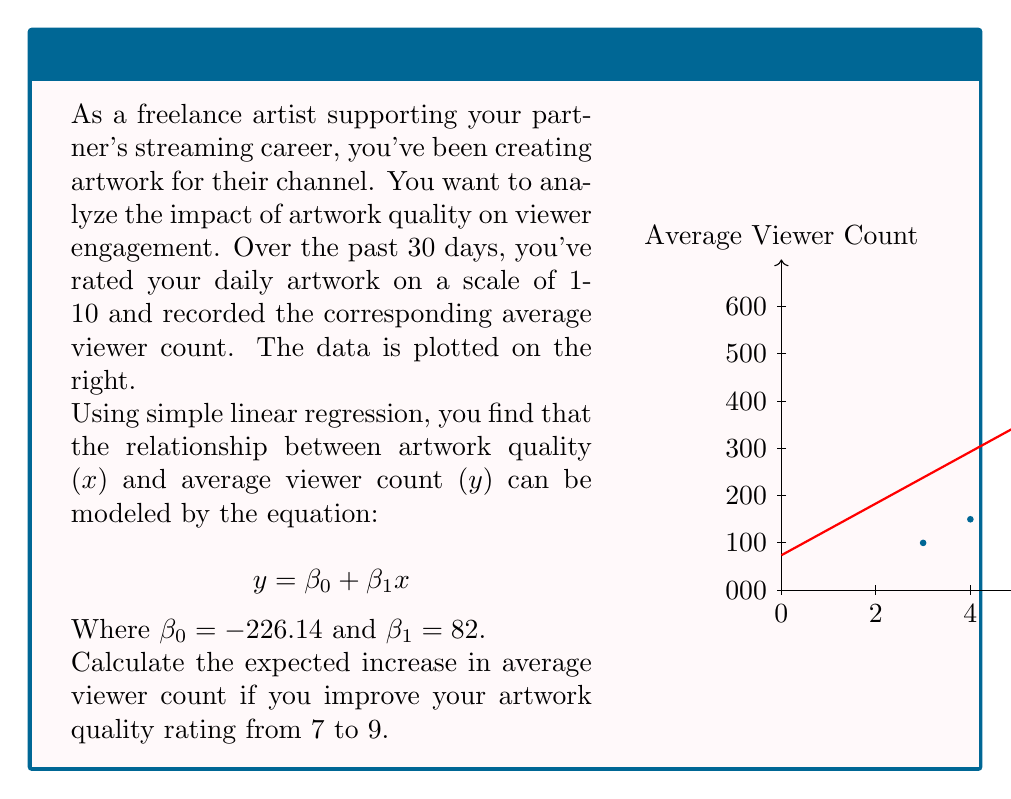Help me with this question. To solve this problem, we'll use the simple linear regression equation:

$$y = \beta_0 + \beta_1x$$

Where:
$y$ is the average viewer count
$x$ is the artwork quality rating
$\beta_0 = -226.14$ (y-intercept)
$\beta_1 = 82$ (slope)

Step 1: Calculate the expected viewer count for an artwork quality rating of 7.
$y_7 = -226.14 + 82(7) = 347.86$

Step 2: Calculate the expected viewer count for an artwork quality rating of 9.
$y_9 = -226.14 + 82(9) = 511.86$

Step 3: Calculate the difference between the two viewer counts.
Increase in viewers = $y_9 - y_7 = 511.86 - 347.86 = 164$

Therefore, improving the artwork quality rating from 7 to 9 is expected to increase the average viewer count by 164.
Answer: 164 viewers 